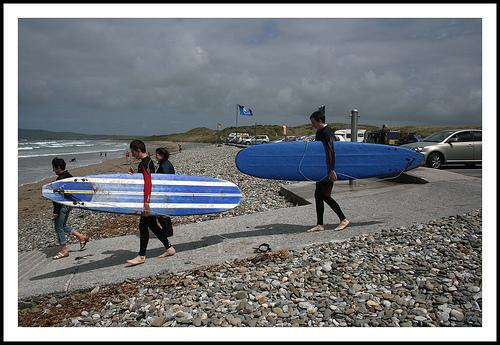Identify a natural element shown multiple times with different X and Y coordinates. White clouds in the blue sky can be seen in multiple instances with different X and Y coordinates. Briefly describe the state of the sky in the image. The sky in the image is cloudy, with several white clouds in the blue sky. What color is the sleeve of a wet suit mentioned in the image? The sleeve of the wet suit is red. What is the dominant color of the flag on the pole? Blue. What type of footwear is mentioned in the image? Silver sandals are mentioned in the image. Refer to a group of people in the image based on their actions and attire. People on their way to go surfing, wearing wetsuits and carrying surfboards down a walkway. Choose a product shown in the image and write a one-sentence advertisement for it. Ride the waves with our sleek and stylish blue surfboards, perfect for a day at the beach with friends and family. Identify an accessory that can be found on top of a surfboard in the image. A white leash can be found on top of a surfboard in the image. Using textual hints from the image, describe an object seen three times in the image. People carrying blue surfboards are seen three times in the image. Which person in the image seems to be wearing full black wet suit? A person carrying a surfboard down the ramp is wearing a full black wet suit. 